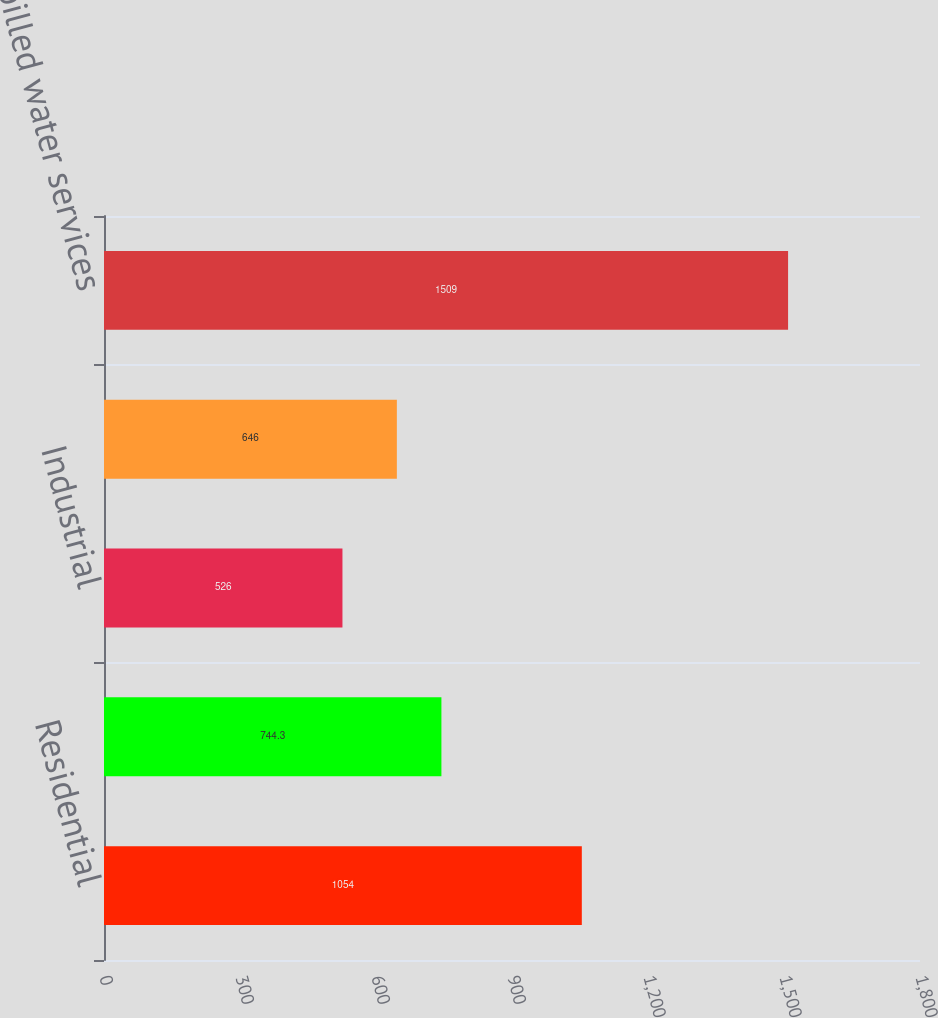Convert chart to OTSL. <chart><loc_0><loc_0><loc_500><loc_500><bar_chart><fcel>Residential<fcel>Commercial<fcel>Industrial<fcel>Public and other<fcel>Total billed water services<nl><fcel>1054<fcel>744.3<fcel>526<fcel>646<fcel>1509<nl></chart> 